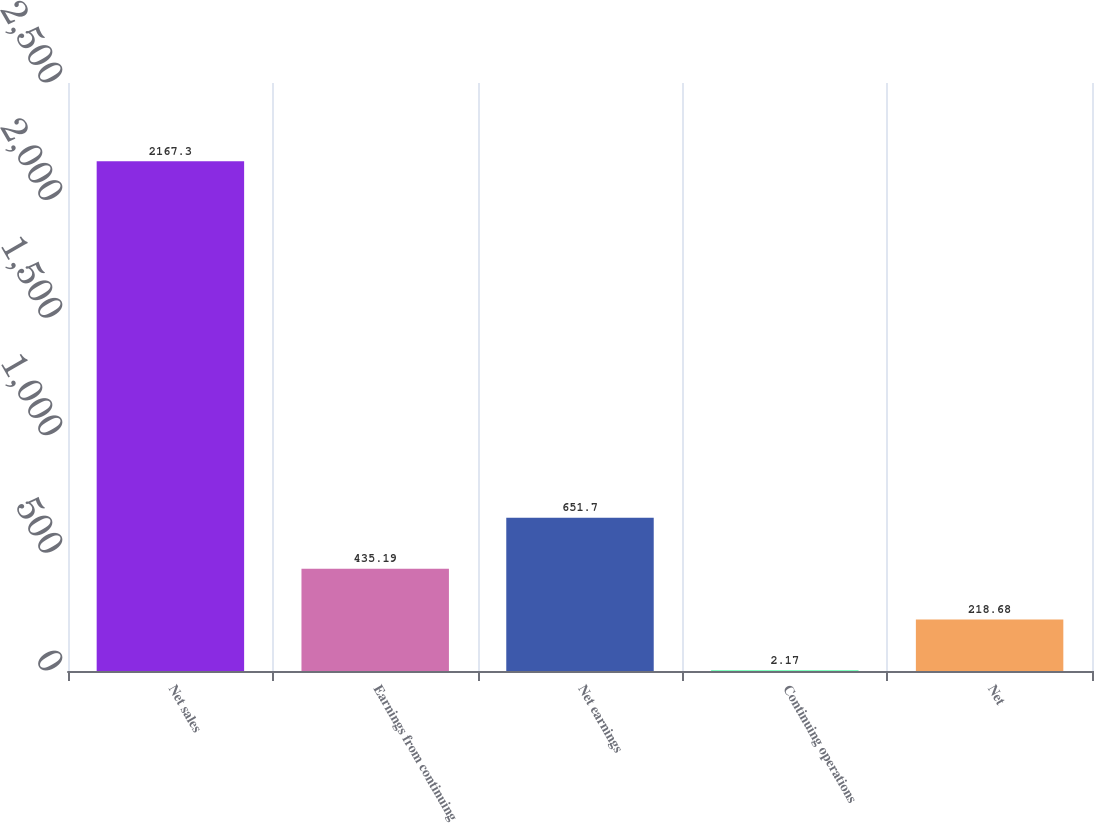<chart> <loc_0><loc_0><loc_500><loc_500><bar_chart><fcel>Net sales<fcel>Earnings from continuing<fcel>Net earnings<fcel>Continuing operations<fcel>Net<nl><fcel>2167.3<fcel>435.19<fcel>651.7<fcel>2.17<fcel>218.68<nl></chart> 